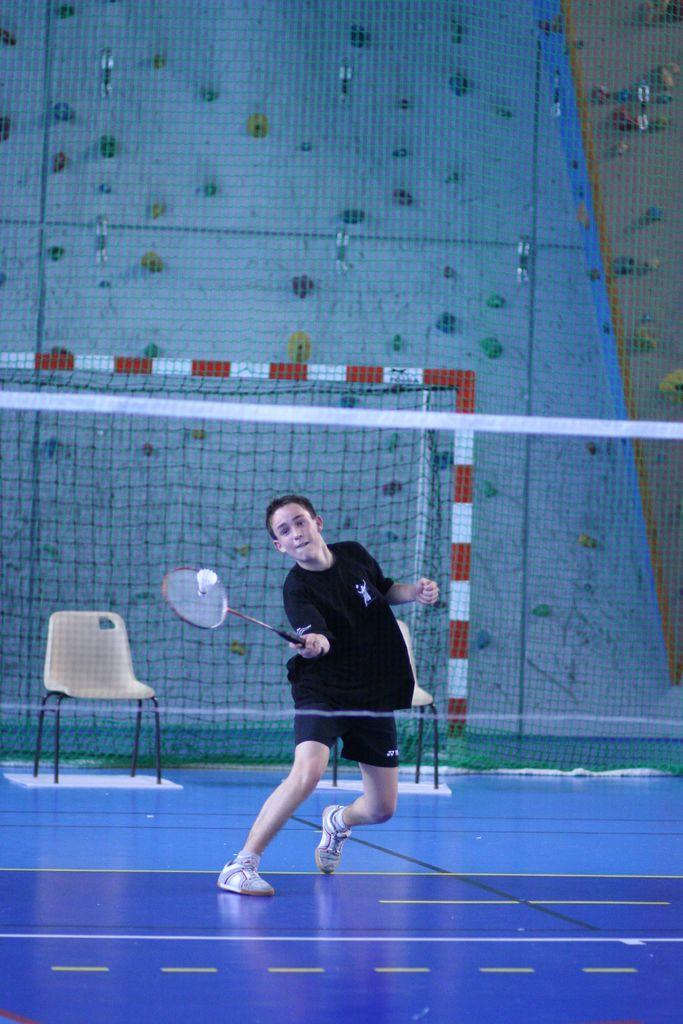In one or two sentences, can you explain what this image depicts? a person is playing badminton. he is wearing a black shirt and a shorts. in front of him there is a net. behind him there is a chair. the floor is blue in color. 